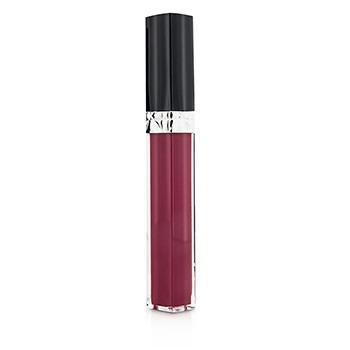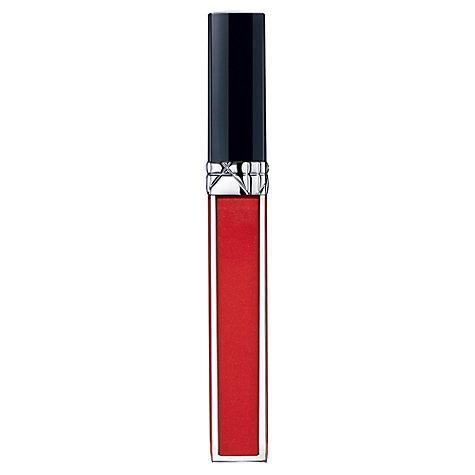The first image is the image on the left, the second image is the image on the right. Assess this claim about the two images: "There is at least one lip gloss applicator out of the tube.". Correct or not? Answer yes or no. No. The first image is the image on the left, the second image is the image on the right. Given the left and right images, does the statement "In each picture, there is one lip gloss tube with a black lid and no label." hold true? Answer yes or no. Yes. 